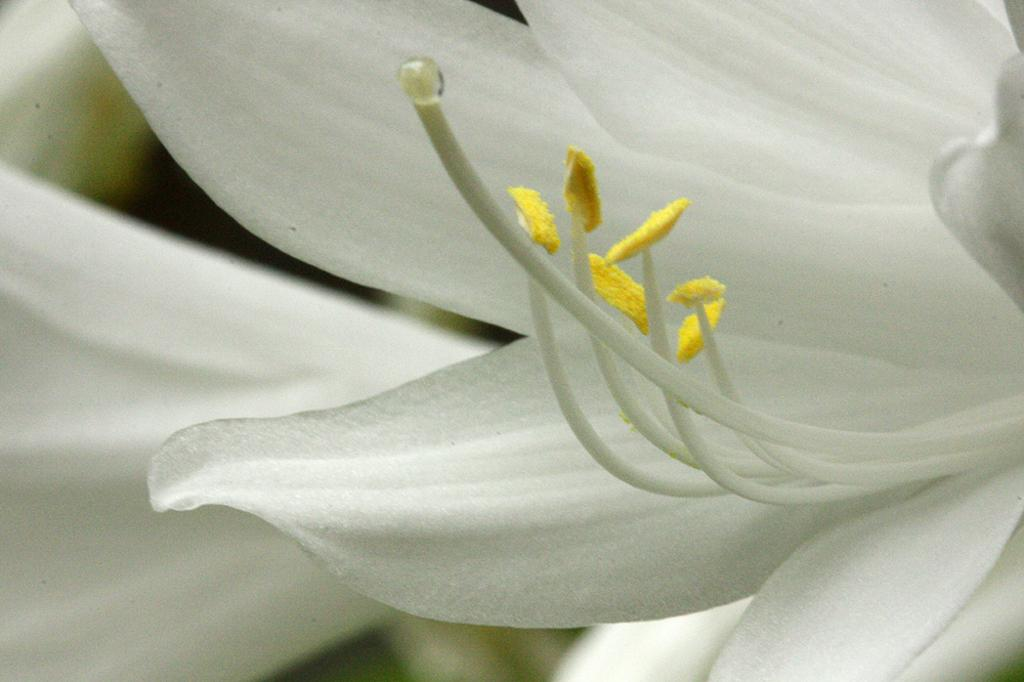What is the main subject of the image? There is a flower in the image. What color is the flower? The flower is white. Are there any specific features of the flower mentioned in the facts? Yes, the flower has pollen grains. What color are the pollen grains? The pollen grains are yellow. Can you describe the background of the image? The background of the image is blurred. How many bombs can be seen in the image? There are no bombs present in the image; it features a white flower with yellow pollen grains against a blurred background. What type of sheet is covering the flower in the image? There is no sheet covering the flower in the image; it is not mentioned in the provided facts. 